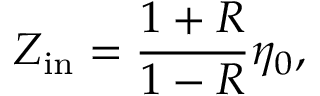Convert formula to latex. <formula><loc_0><loc_0><loc_500><loc_500>Z _ { i n } = \frac { 1 + R } { 1 - R } \eta _ { 0 } ,</formula> 